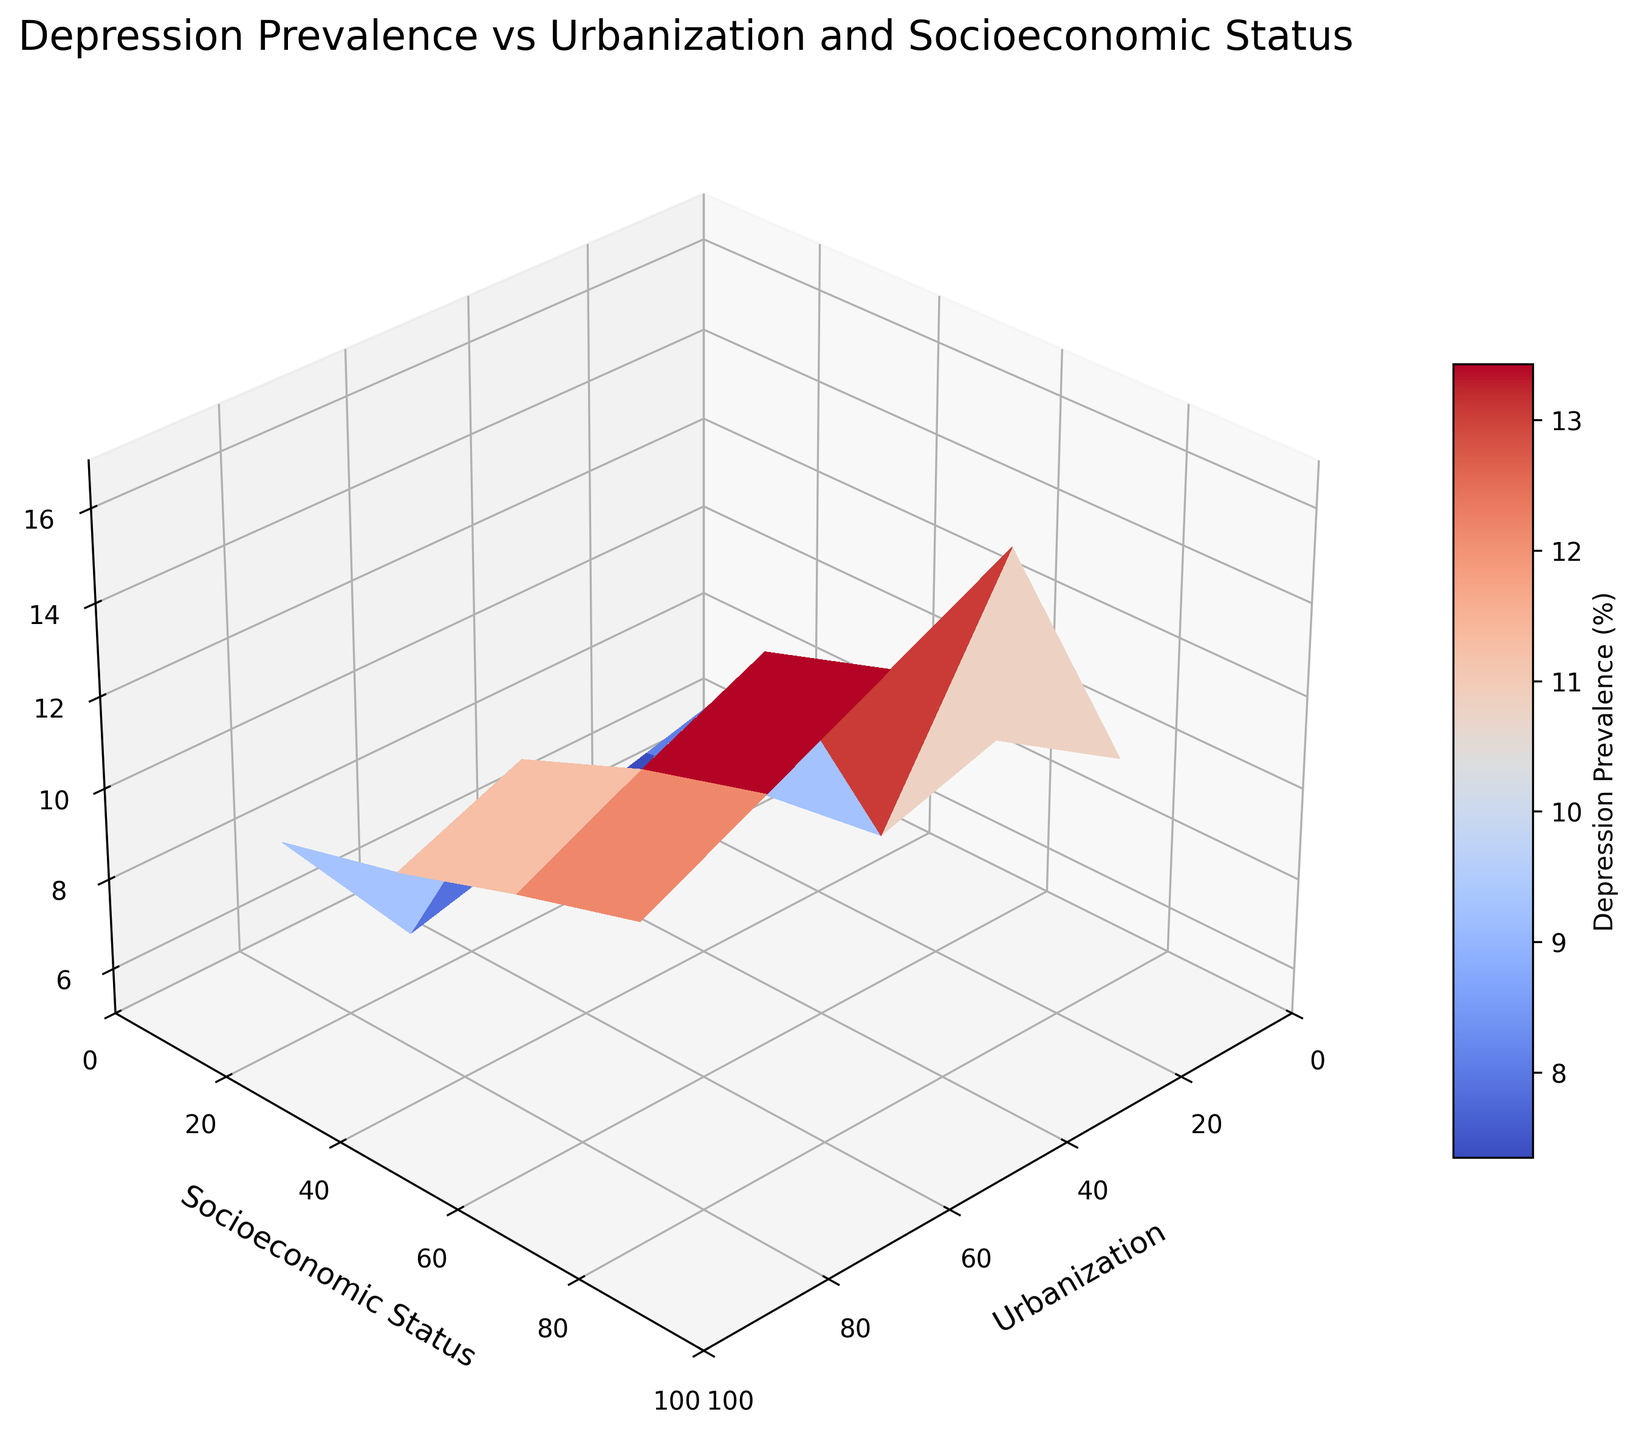What is the title of the figure? The title is located at the top center of the figure and indicates the main topic or purpose. By examining the figure, we can see the title in the text.
Answer: Depression Prevalence vs Urbanization and Socioeconomic Status What does the z-axis represent? The z-axis is labeled along the vertical dimension of the figure. By looking at the label, we can identify what it represents.
Answer: Depression Prevalence (%) What color gradient is used in the figure? The surface plot uses a color gradient to represent different values. We can observe the color transitions to determine the gradient used.
Answer: Coolwarm How does depression prevalence change with increasing urbanization for a socioeconomic status of 20? To answer this, examine the area in the surface plot where socioeconomic status is 20 and observe the trend as urbanization increases.
Answer: Depression prevalence increases At which socioeconomic status and urbanization is depression prevalence the highest? By examining the z-values (height) across the surface plot, locate the highest point and note its corresponding x (urbanization) and y (socioeconomic status) values.
Answer: Socioeconomic status of 20 and urbanization of 90 Compare the depression prevalence between urbanization levels 10 and 90 at a socioeconomic status of 60. Which is higher? Find the points on the surface plot where socioeconomic status is 60 and compare the z-values (heights) for urbanization levels 10 and 90.
Answer: Urbanization of 90 Is there a general trend in depression prevalence as socioeconomic status increases at an urbanization level of 50? Examine the surface plot along the line where urbanization is 50 and observe how the z-values (heights) change as socioeconomic status increases.
Answer: Depression prevalence decreases What is the approximate depression prevalence at an urbanization level of 30 and a socioeconomic status of 40? Locate the point on the surface plot at urbanization level 30 and socioeconomic status 40, and read off the z-value (height).
Answer: ~8.7 Does depression prevalence peak at high or low socioeconomic statuses for given urbanization levels? Observe the z-values (heights) at both high and low ends of socioeconomic status across various urbanization levels to see where they are higher.
Answer: Low socioeconomic statuses Given the trend displayed, what could be a recommendation for reducing depression prevalence in highly urbanized areas? Analyze the overall trends and patterns visible in the figure to make an informed recommendation.
Answer: Improve socioeconomic status 